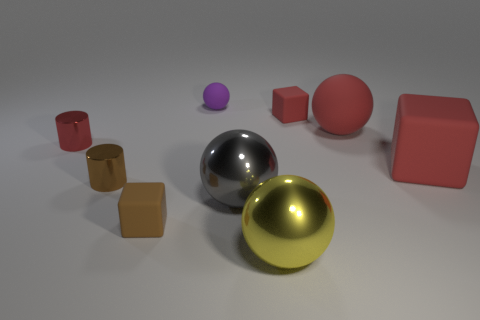The purple sphere that is the same material as the large cube is what size?
Offer a terse response. Small. What number of other objects are there of the same shape as the gray metal object?
Ensure brevity in your answer.  3. Is the size of the brown rubber block the same as the red rubber sphere?
Offer a terse response. No. Is the size of the red shiny cylinder the same as the rubber sphere in front of the tiny purple rubber ball?
Offer a terse response. No. Is the shape of the large gray metal thing the same as the big rubber thing in front of the large red sphere?
Give a very brief answer. No. What material is the tiny brown cube?
Your response must be concise. Rubber. How many metal things are either small purple things or small cyan blocks?
Give a very brief answer. 0. Is the number of small purple balls in front of the big gray sphere less than the number of rubber cubes that are right of the red matte sphere?
Offer a very short reply. Yes. Is there a brown object in front of the big red thing to the right of the matte ball that is right of the large gray sphere?
Your response must be concise. Yes. There is a big cube that is the same color as the big matte ball; what is its material?
Your response must be concise. Rubber. 